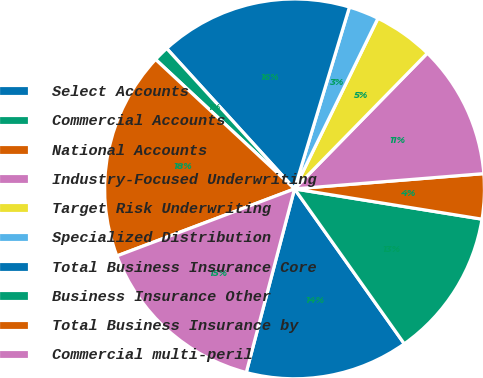Convert chart to OTSL. <chart><loc_0><loc_0><loc_500><loc_500><pie_chart><fcel>Select Accounts<fcel>Commercial Accounts<fcel>National Accounts<fcel>Industry-Focused Underwriting<fcel>Target Risk Underwriting<fcel>Specialized Distribution<fcel>Total Business Insurance Core<fcel>Business Insurance Other<fcel>Total Business Insurance by<fcel>Commercial multi-peril<nl><fcel>13.9%<fcel>12.64%<fcel>3.83%<fcel>11.39%<fcel>5.09%<fcel>2.57%<fcel>16.42%<fcel>1.31%<fcel>17.68%<fcel>15.16%<nl></chart> 